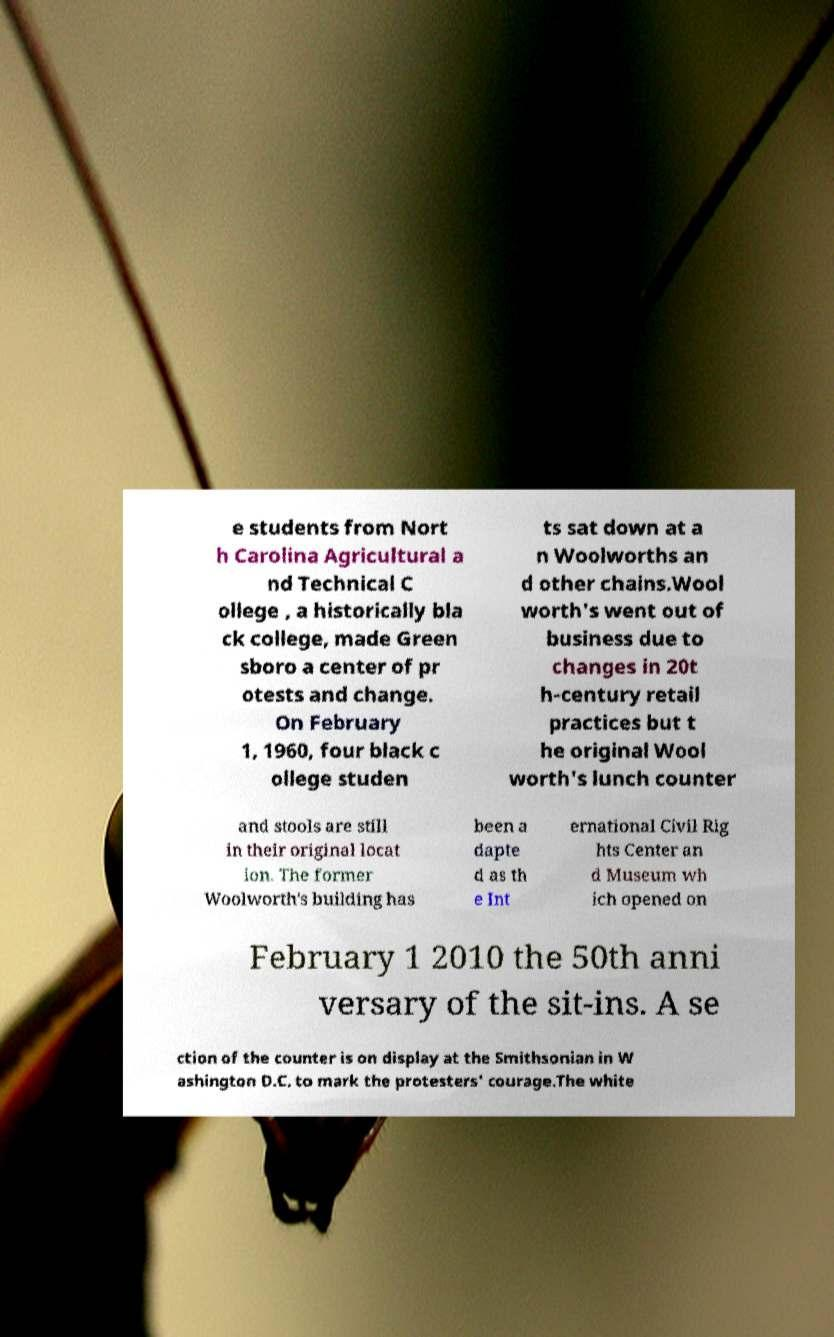What messages or text are displayed in this image? I need them in a readable, typed format. e students from Nort h Carolina Agricultural a nd Technical C ollege , a historically bla ck college, made Green sboro a center of pr otests and change. On February 1, 1960, four black c ollege studen ts sat down at a n Woolworths an d other chains.Wool worth's went out of business due to changes in 20t h-century retail practices but t he original Wool worth's lunch counter and stools are still in their original locat ion. The former Woolworth's building has been a dapte d as th e Int ernational Civil Rig hts Center an d Museum wh ich opened on February 1 2010 the 50th anni versary of the sit-ins. A se ction of the counter is on display at the Smithsonian in W ashington D.C. to mark the protesters' courage.The white 